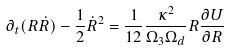Convert formula to latex. <formula><loc_0><loc_0><loc_500><loc_500>\partial _ { t } ( R \dot { R } ) - \frac { 1 } { 2 } { { \dot { R } } ^ { 2 } } = \frac { 1 } { 1 2 } \frac { \kappa ^ { 2 } } { \Omega _ { 3 } \Omega _ { d } } R \frac { \partial U } { \partial R }</formula> 